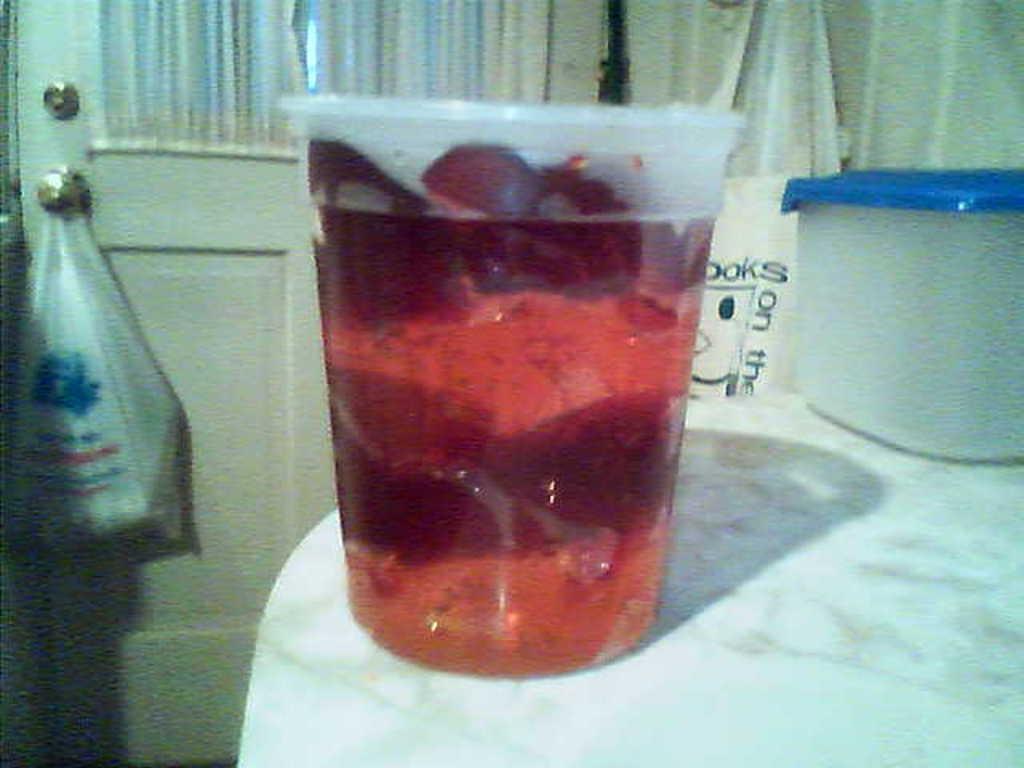Could you give a brief overview of what you see in this image? In this picture there is a glass in the center of the image, which contains juice in it and there is a box on the right side of the image, there is a door and a polythene in the background area of the image. 